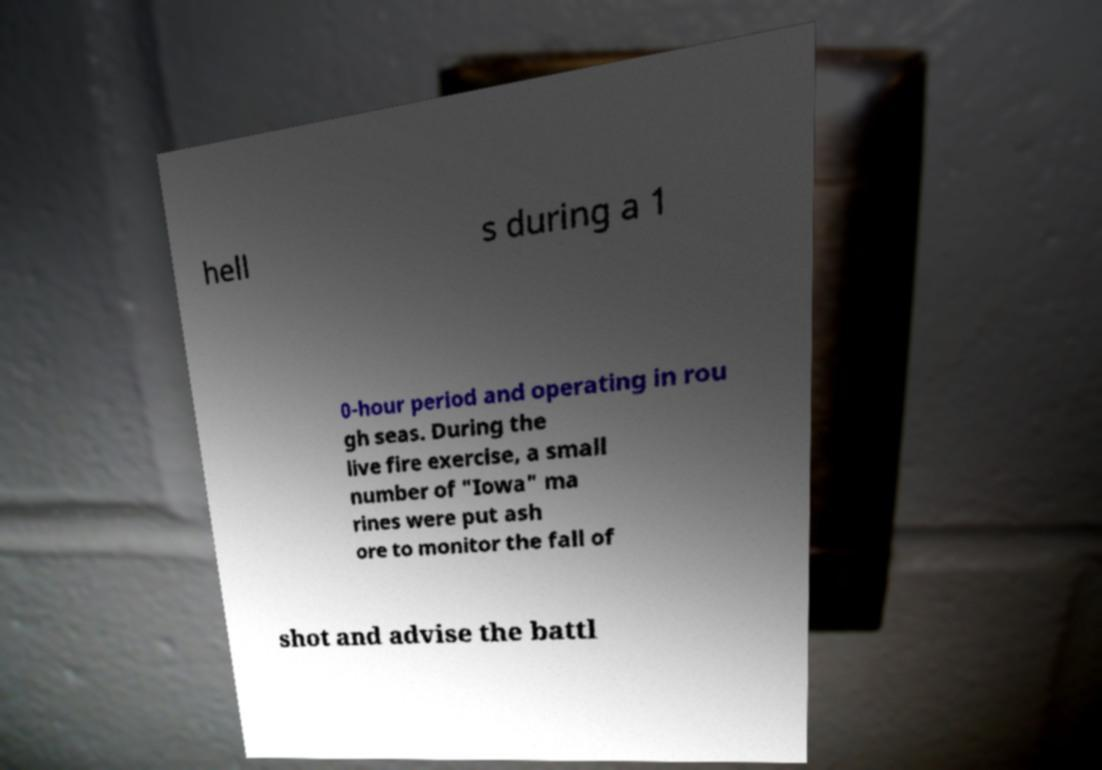I need the written content from this picture converted into text. Can you do that? hell s during a 1 0-hour period and operating in rou gh seas. During the live fire exercise, a small number of "Iowa" ma rines were put ash ore to monitor the fall of shot and advise the battl 